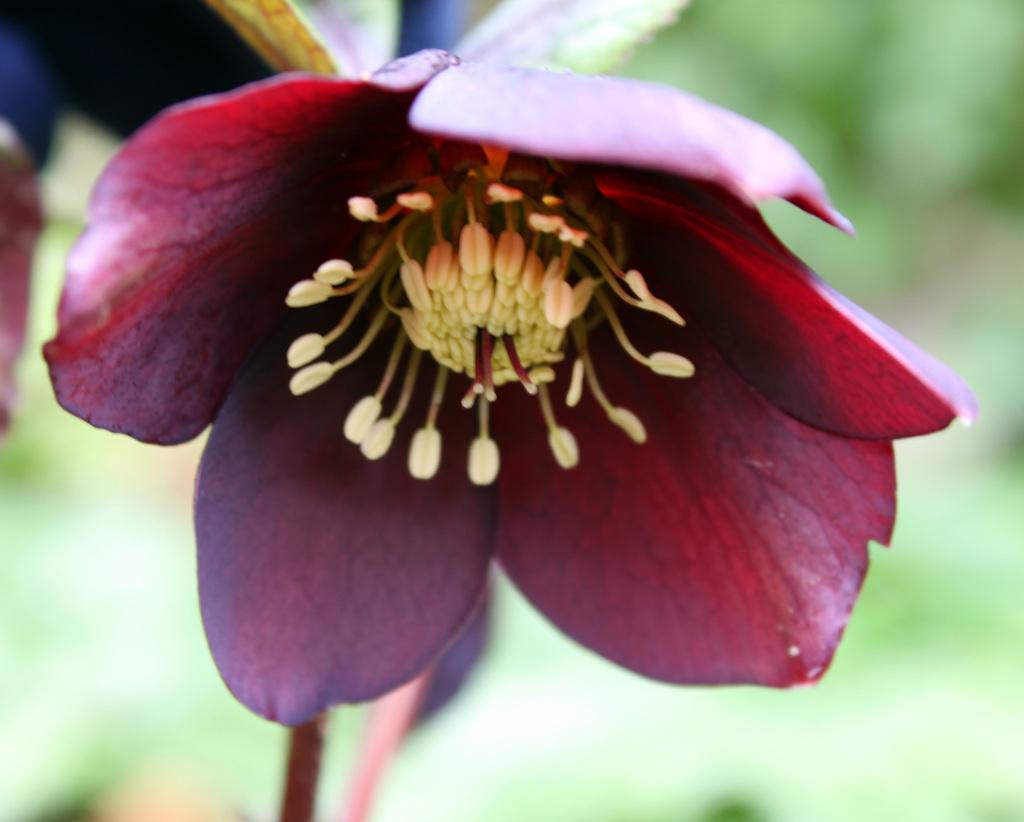What is the main subject in the foreground of the image? There is a flower in the foreground of the image. How would you describe the background of the image? The background of the image is blurred. What type of wax can be seen dripping from the jeans in the image? There are no jeans or wax present in the image; it features a flower in the foreground and a blurred background. 